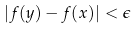<formula> <loc_0><loc_0><loc_500><loc_500>| f ( y ) - f ( x ) | < \epsilon</formula> 